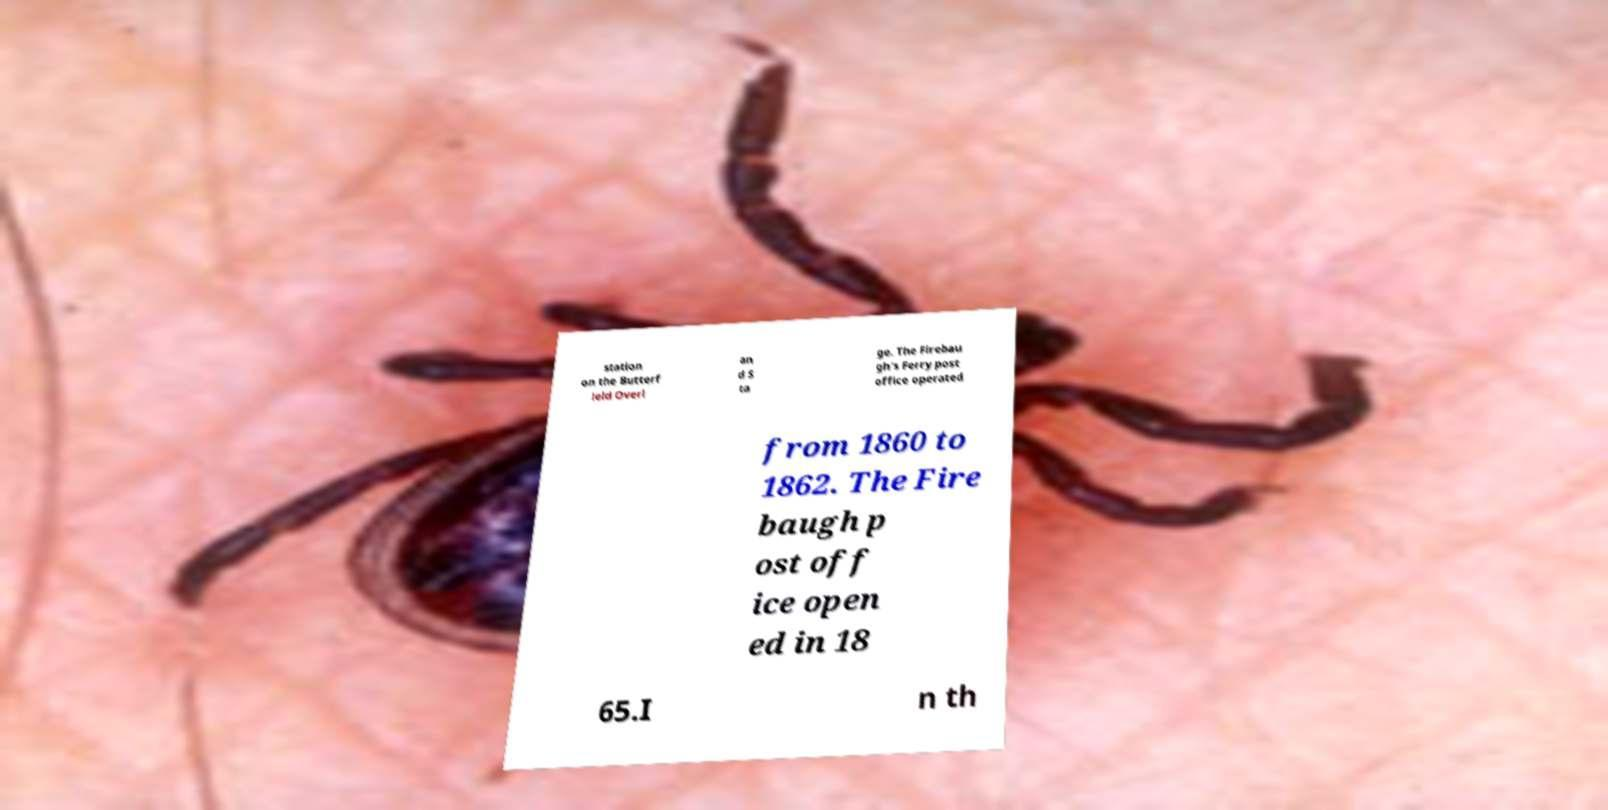There's text embedded in this image that I need extracted. Can you transcribe it verbatim? station on the Butterf ield Overl an d S ta ge. The Firebau gh's Ferry post office operated from 1860 to 1862. The Fire baugh p ost off ice open ed in 18 65.I n th 